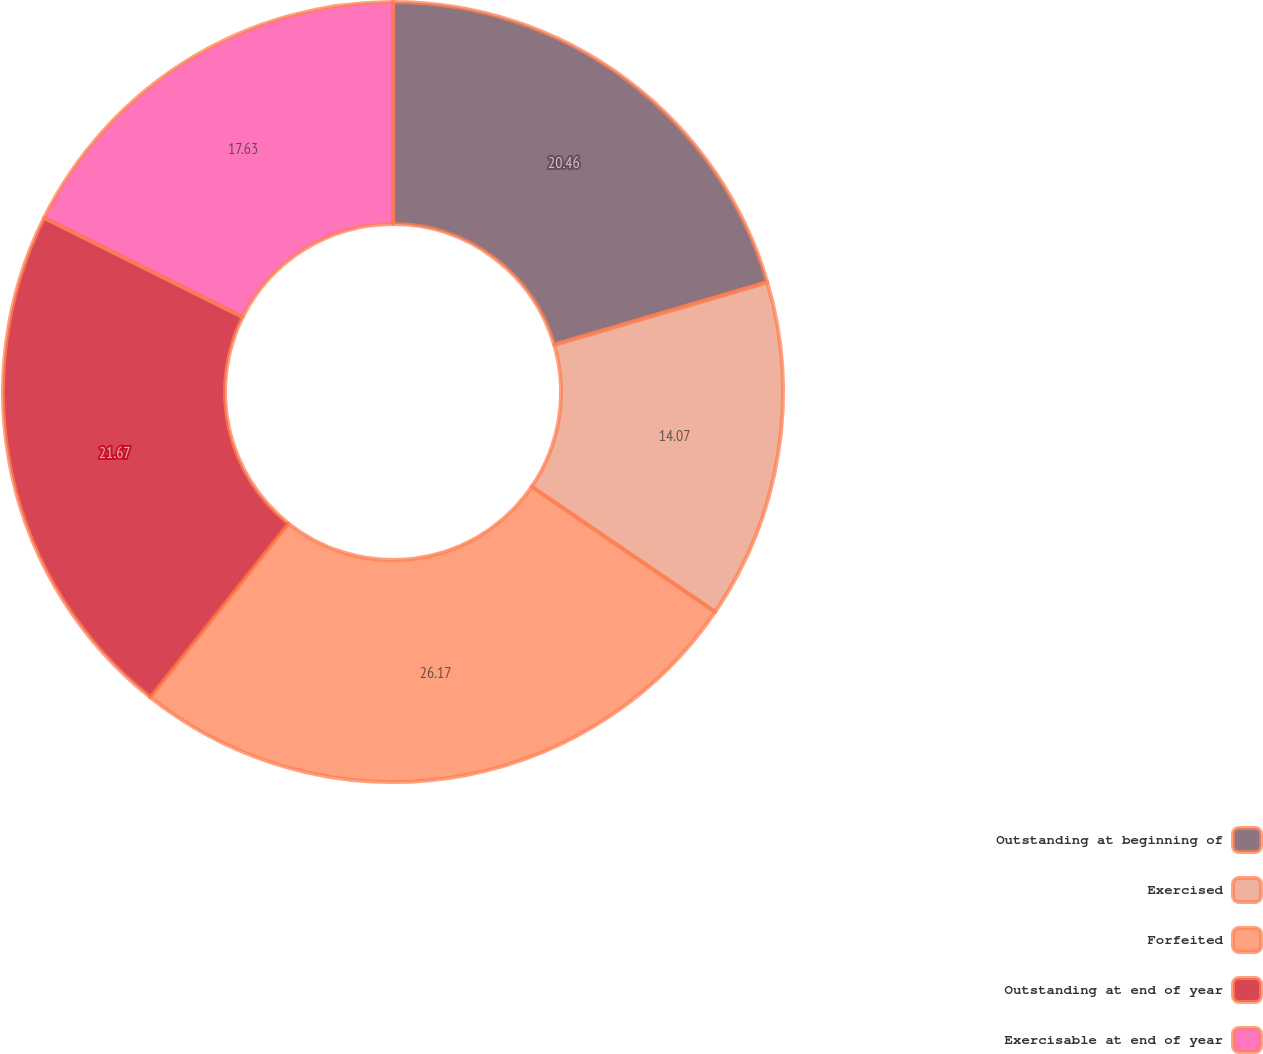Convert chart. <chart><loc_0><loc_0><loc_500><loc_500><pie_chart><fcel>Outstanding at beginning of<fcel>Exercised<fcel>Forfeited<fcel>Outstanding at end of year<fcel>Exercisable at end of year<nl><fcel>20.46%<fcel>14.07%<fcel>26.17%<fcel>21.67%<fcel>17.63%<nl></chart> 